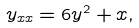<formula> <loc_0><loc_0><loc_500><loc_500>y _ { x x } = 6 y ^ { 2 } + x ,</formula> 